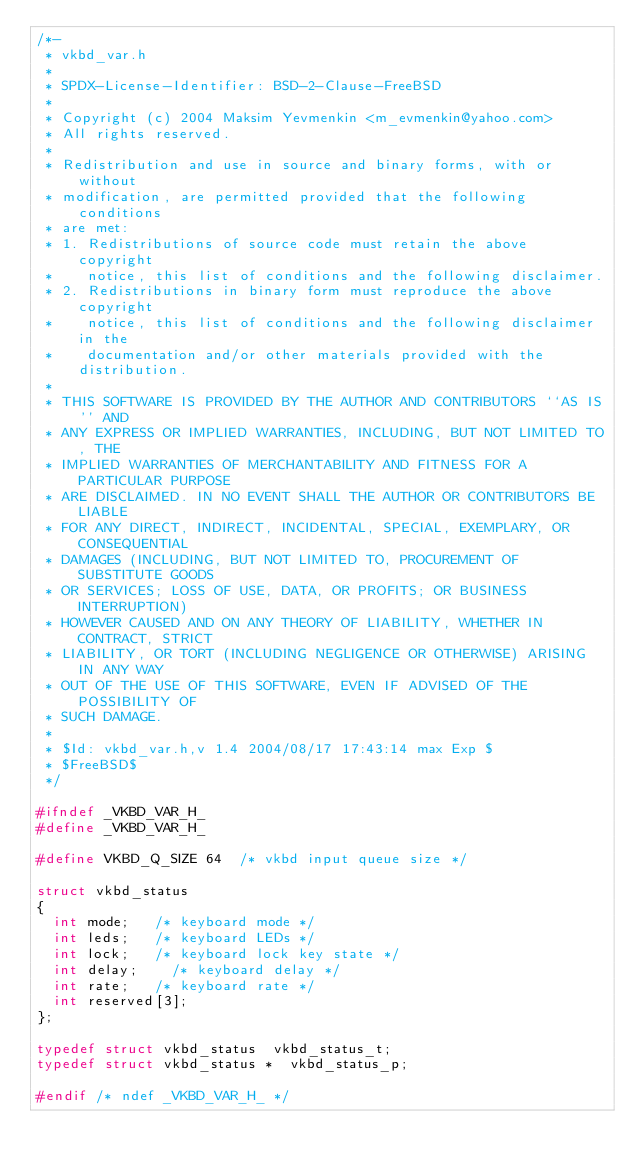<code> <loc_0><loc_0><loc_500><loc_500><_C_>/*-
 * vkbd_var.h
 *
 * SPDX-License-Identifier: BSD-2-Clause-FreeBSD
 *
 * Copyright (c) 2004 Maksim Yevmenkin <m_evmenkin@yahoo.com>
 * All rights reserved.
 *
 * Redistribution and use in source and binary forms, with or without
 * modification, are permitted provided that the following conditions
 * are met:
 * 1. Redistributions of source code must retain the above copyright
 *    notice, this list of conditions and the following disclaimer.
 * 2. Redistributions in binary form must reproduce the above copyright
 *    notice, this list of conditions and the following disclaimer in the
 *    documentation and/or other materials provided with the distribution.
 *
 * THIS SOFTWARE IS PROVIDED BY THE AUTHOR AND CONTRIBUTORS ``AS IS'' AND
 * ANY EXPRESS OR IMPLIED WARRANTIES, INCLUDING, BUT NOT LIMITED TO, THE
 * IMPLIED WARRANTIES OF MERCHANTABILITY AND FITNESS FOR A PARTICULAR PURPOSE
 * ARE DISCLAIMED. IN NO EVENT SHALL THE AUTHOR OR CONTRIBUTORS BE LIABLE
 * FOR ANY DIRECT, INDIRECT, INCIDENTAL, SPECIAL, EXEMPLARY, OR CONSEQUENTIAL
 * DAMAGES (INCLUDING, BUT NOT LIMITED TO, PROCUREMENT OF SUBSTITUTE GOODS
 * OR SERVICES; LOSS OF USE, DATA, OR PROFITS; OR BUSINESS INTERRUPTION)
 * HOWEVER CAUSED AND ON ANY THEORY OF LIABILITY, WHETHER IN CONTRACT, STRICT
 * LIABILITY, OR TORT (INCLUDING NEGLIGENCE OR OTHERWISE) ARISING IN ANY WAY
 * OUT OF THE USE OF THIS SOFTWARE, EVEN IF ADVISED OF THE POSSIBILITY OF
 * SUCH DAMAGE.
 *
 * $Id: vkbd_var.h,v 1.4 2004/08/17 17:43:14 max Exp $
 * $FreeBSD$
 */

#ifndef _VKBD_VAR_H_
#define _VKBD_VAR_H_

#define	VKBD_Q_SIZE	64	/* vkbd input queue size */

struct vkbd_status
{
	int	mode;		/* keyboard mode */
	int	leds;		/* keyboard LEDs */
	int	lock;		/* keyboard lock key state */
	int	delay;		/* keyboard delay */
	int	rate;		/* keyboard rate */
	int	reserved[3];
};

typedef struct vkbd_status	vkbd_status_t;
typedef struct vkbd_status *	vkbd_status_p;

#endif /* ndef _VKBD_VAR_H_ */

</code> 